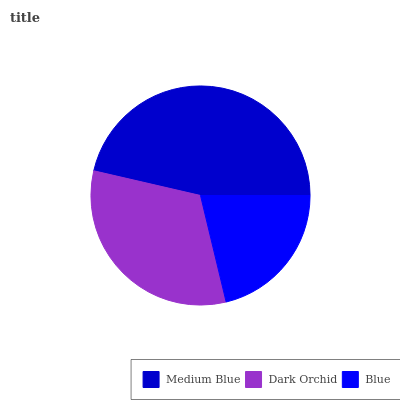Is Blue the minimum?
Answer yes or no. Yes. Is Medium Blue the maximum?
Answer yes or no. Yes. Is Dark Orchid the minimum?
Answer yes or no. No. Is Dark Orchid the maximum?
Answer yes or no. No. Is Medium Blue greater than Dark Orchid?
Answer yes or no. Yes. Is Dark Orchid less than Medium Blue?
Answer yes or no. Yes. Is Dark Orchid greater than Medium Blue?
Answer yes or no. No. Is Medium Blue less than Dark Orchid?
Answer yes or no. No. Is Dark Orchid the high median?
Answer yes or no. Yes. Is Dark Orchid the low median?
Answer yes or no. Yes. Is Medium Blue the high median?
Answer yes or no. No. Is Medium Blue the low median?
Answer yes or no. No. 